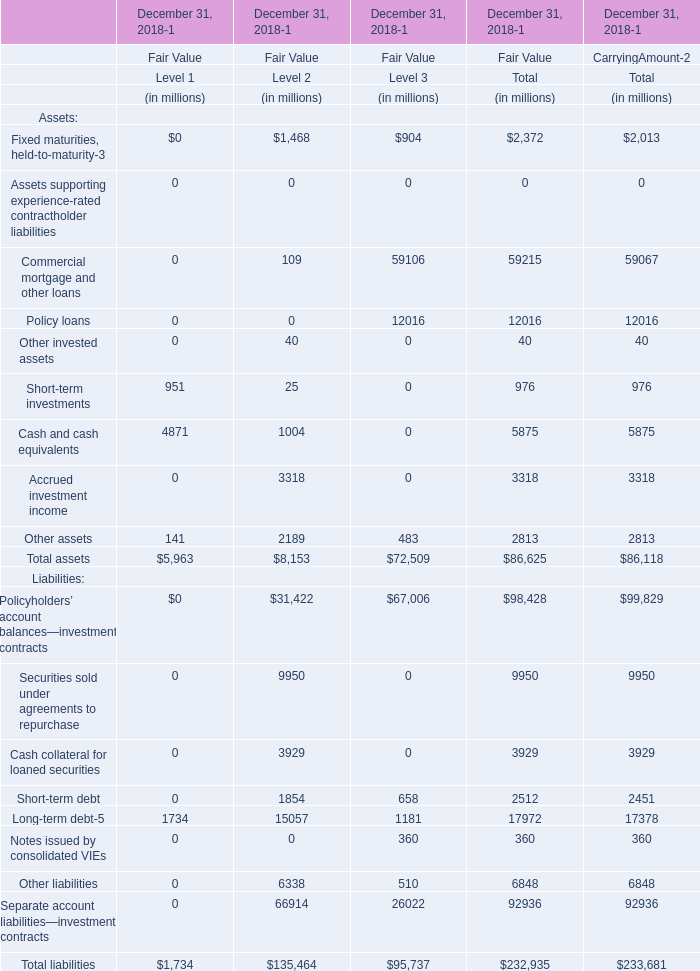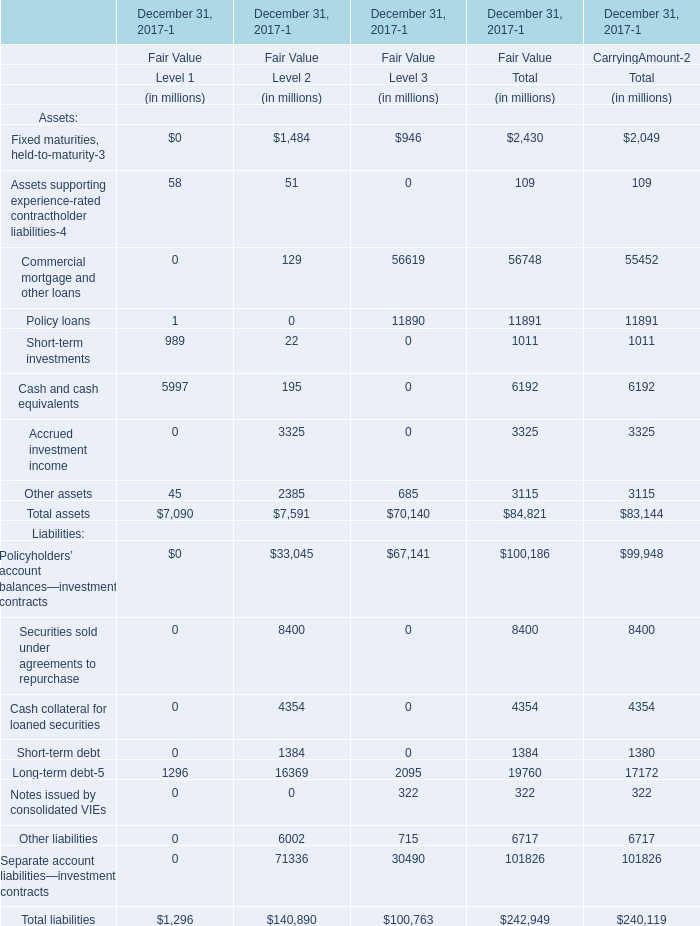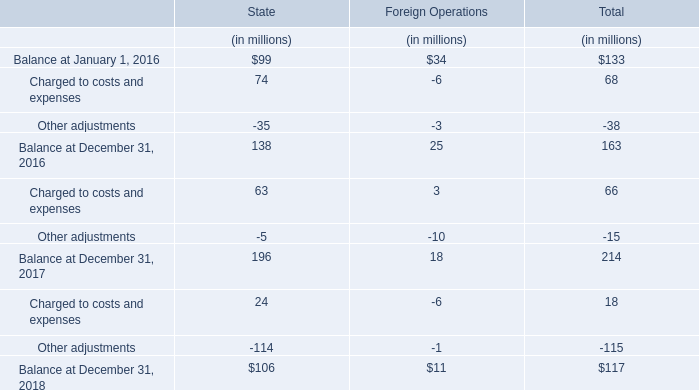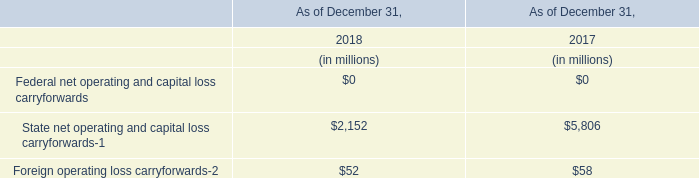How many Level 1 exceed the average of Level 1 in 2018? 
Answer: 3. 